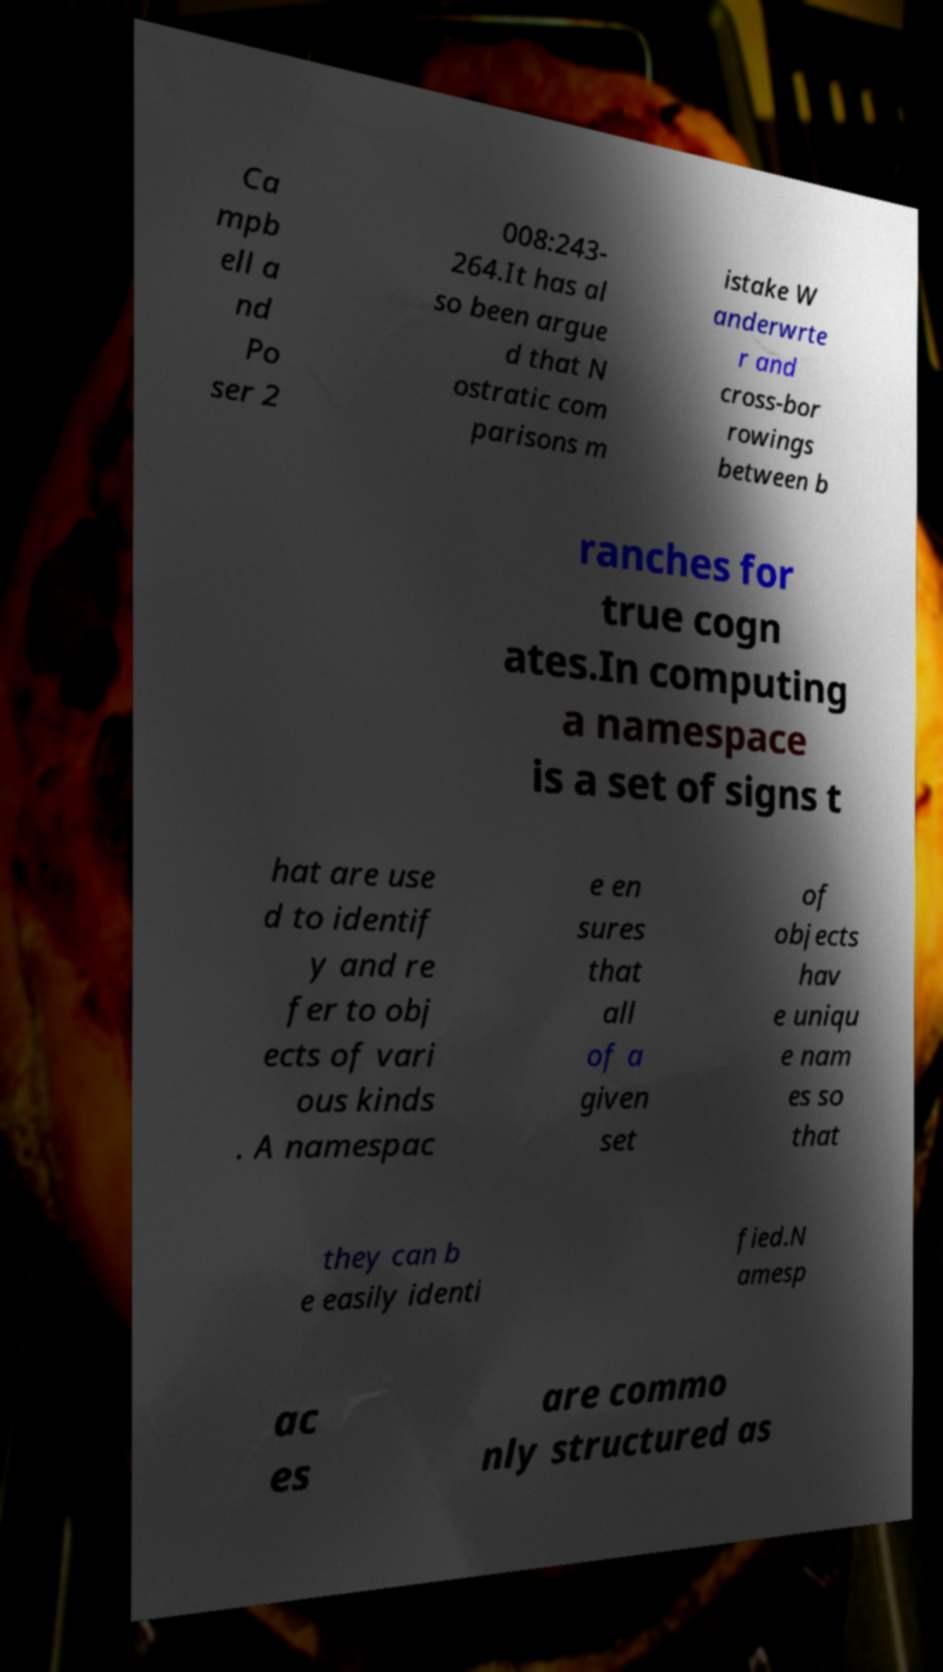I need the written content from this picture converted into text. Can you do that? Ca mpb ell a nd Po ser 2 008:243- 264.It has al so been argue d that N ostratic com parisons m istake W anderwrte r and cross-bor rowings between b ranches for true cogn ates.In computing a namespace is a set of signs t hat are use d to identif y and re fer to obj ects of vari ous kinds . A namespac e en sures that all of a given set of objects hav e uniqu e nam es so that they can b e easily identi fied.N amesp ac es are commo nly structured as 